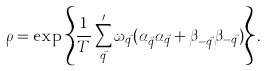<formula> <loc_0><loc_0><loc_500><loc_500>\rho = \exp \left \{ \frac { 1 } { T } \sum _ { \vec { q } } ^ { \prime } \omega _ { \vec { q } } ( \alpha ^ { \dag } _ { \vec { q } } \alpha _ { \vec { q } } + \beta ^ { \dag } _ { - \vec { q } } \beta _ { - \vec { q } } ) \right \} .</formula> 